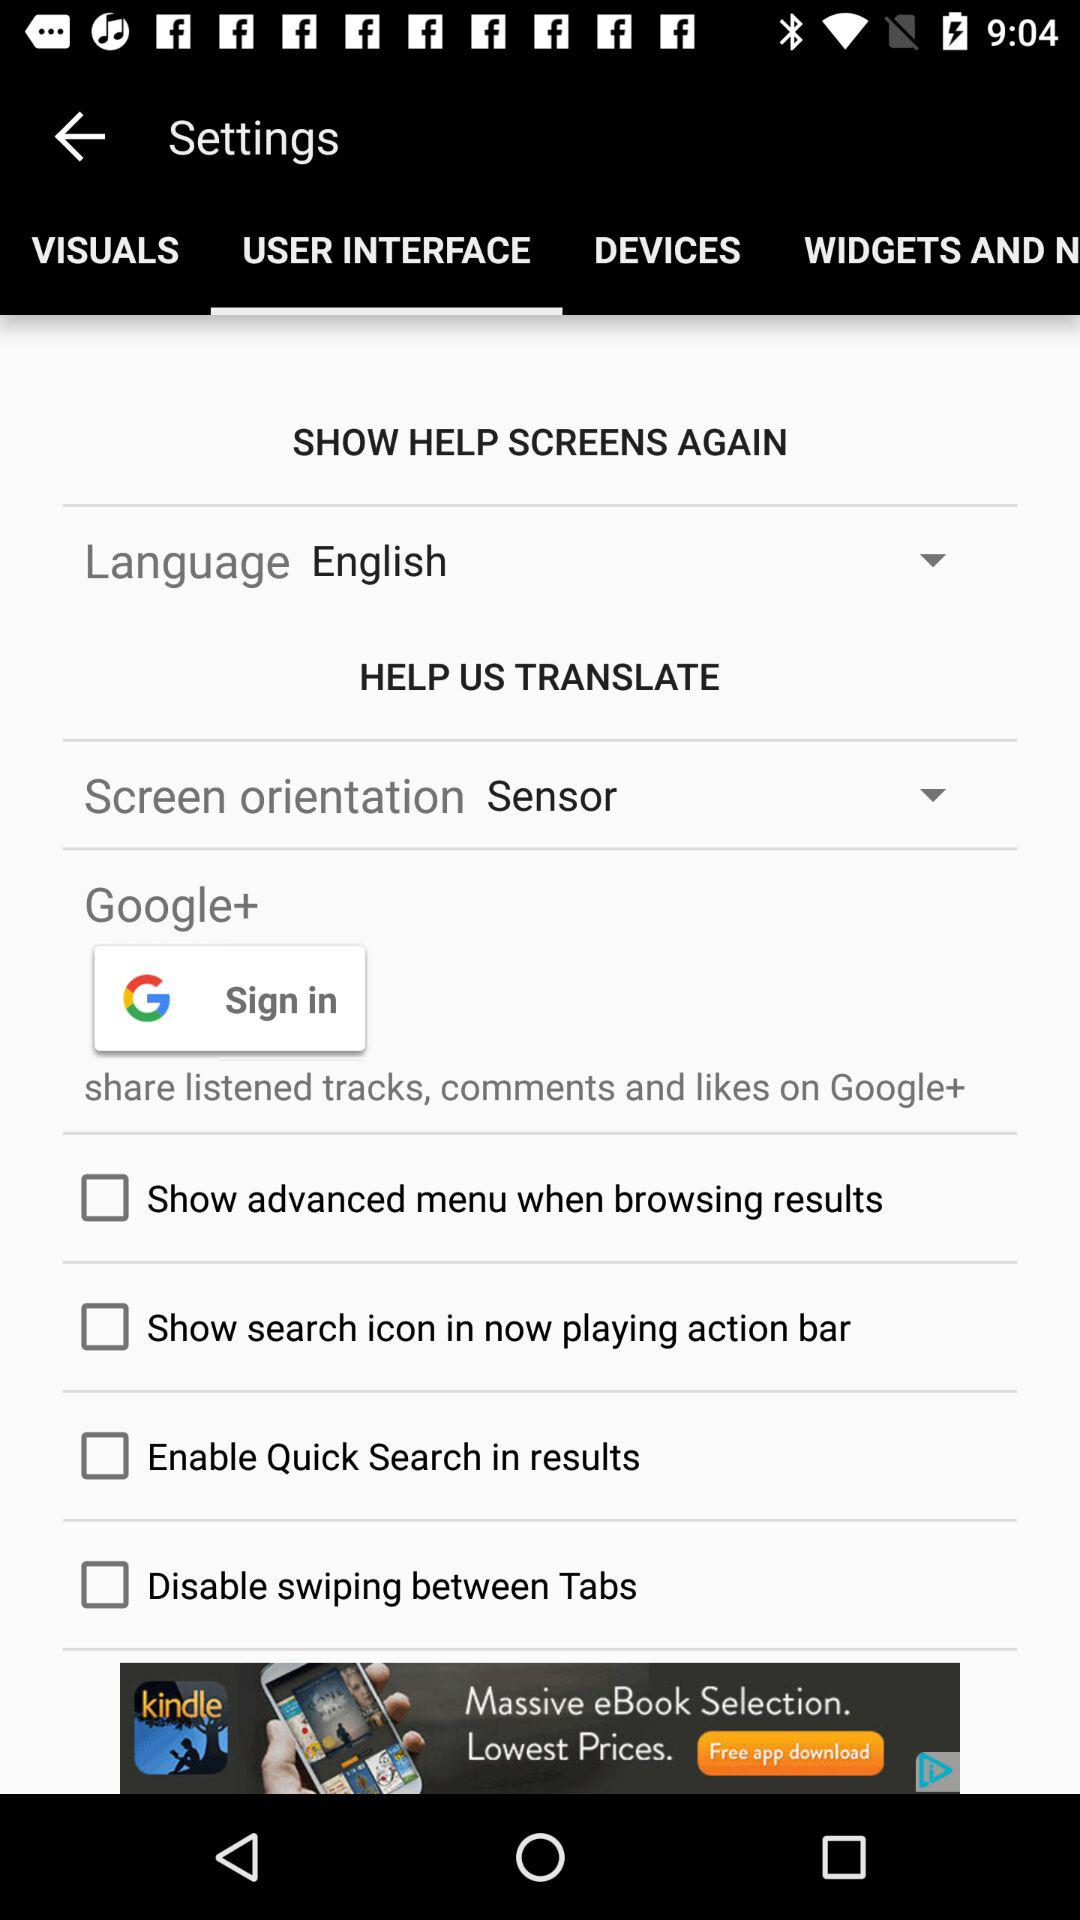Which language is selected in the language setting? The language is English. 